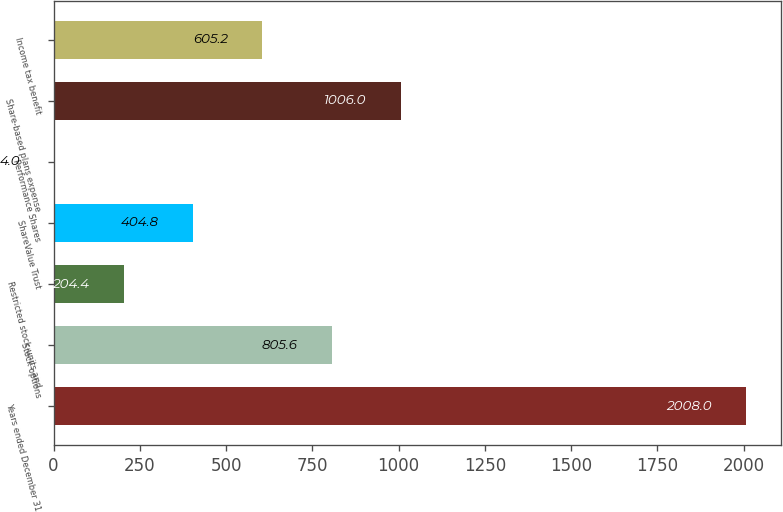Convert chart to OTSL. <chart><loc_0><loc_0><loc_500><loc_500><bar_chart><fcel>Years ended December 31<fcel>Stock options<fcel>Restricted stock units and<fcel>ShareValue Trust<fcel>Performance Shares<fcel>Share-based plans expense<fcel>Income tax benefit<nl><fcel>2008<fcel>805.6<fcel>204.4<fcel>404.8<fcel>4<fcel>1006<fcel>605.2<nl></chart> 